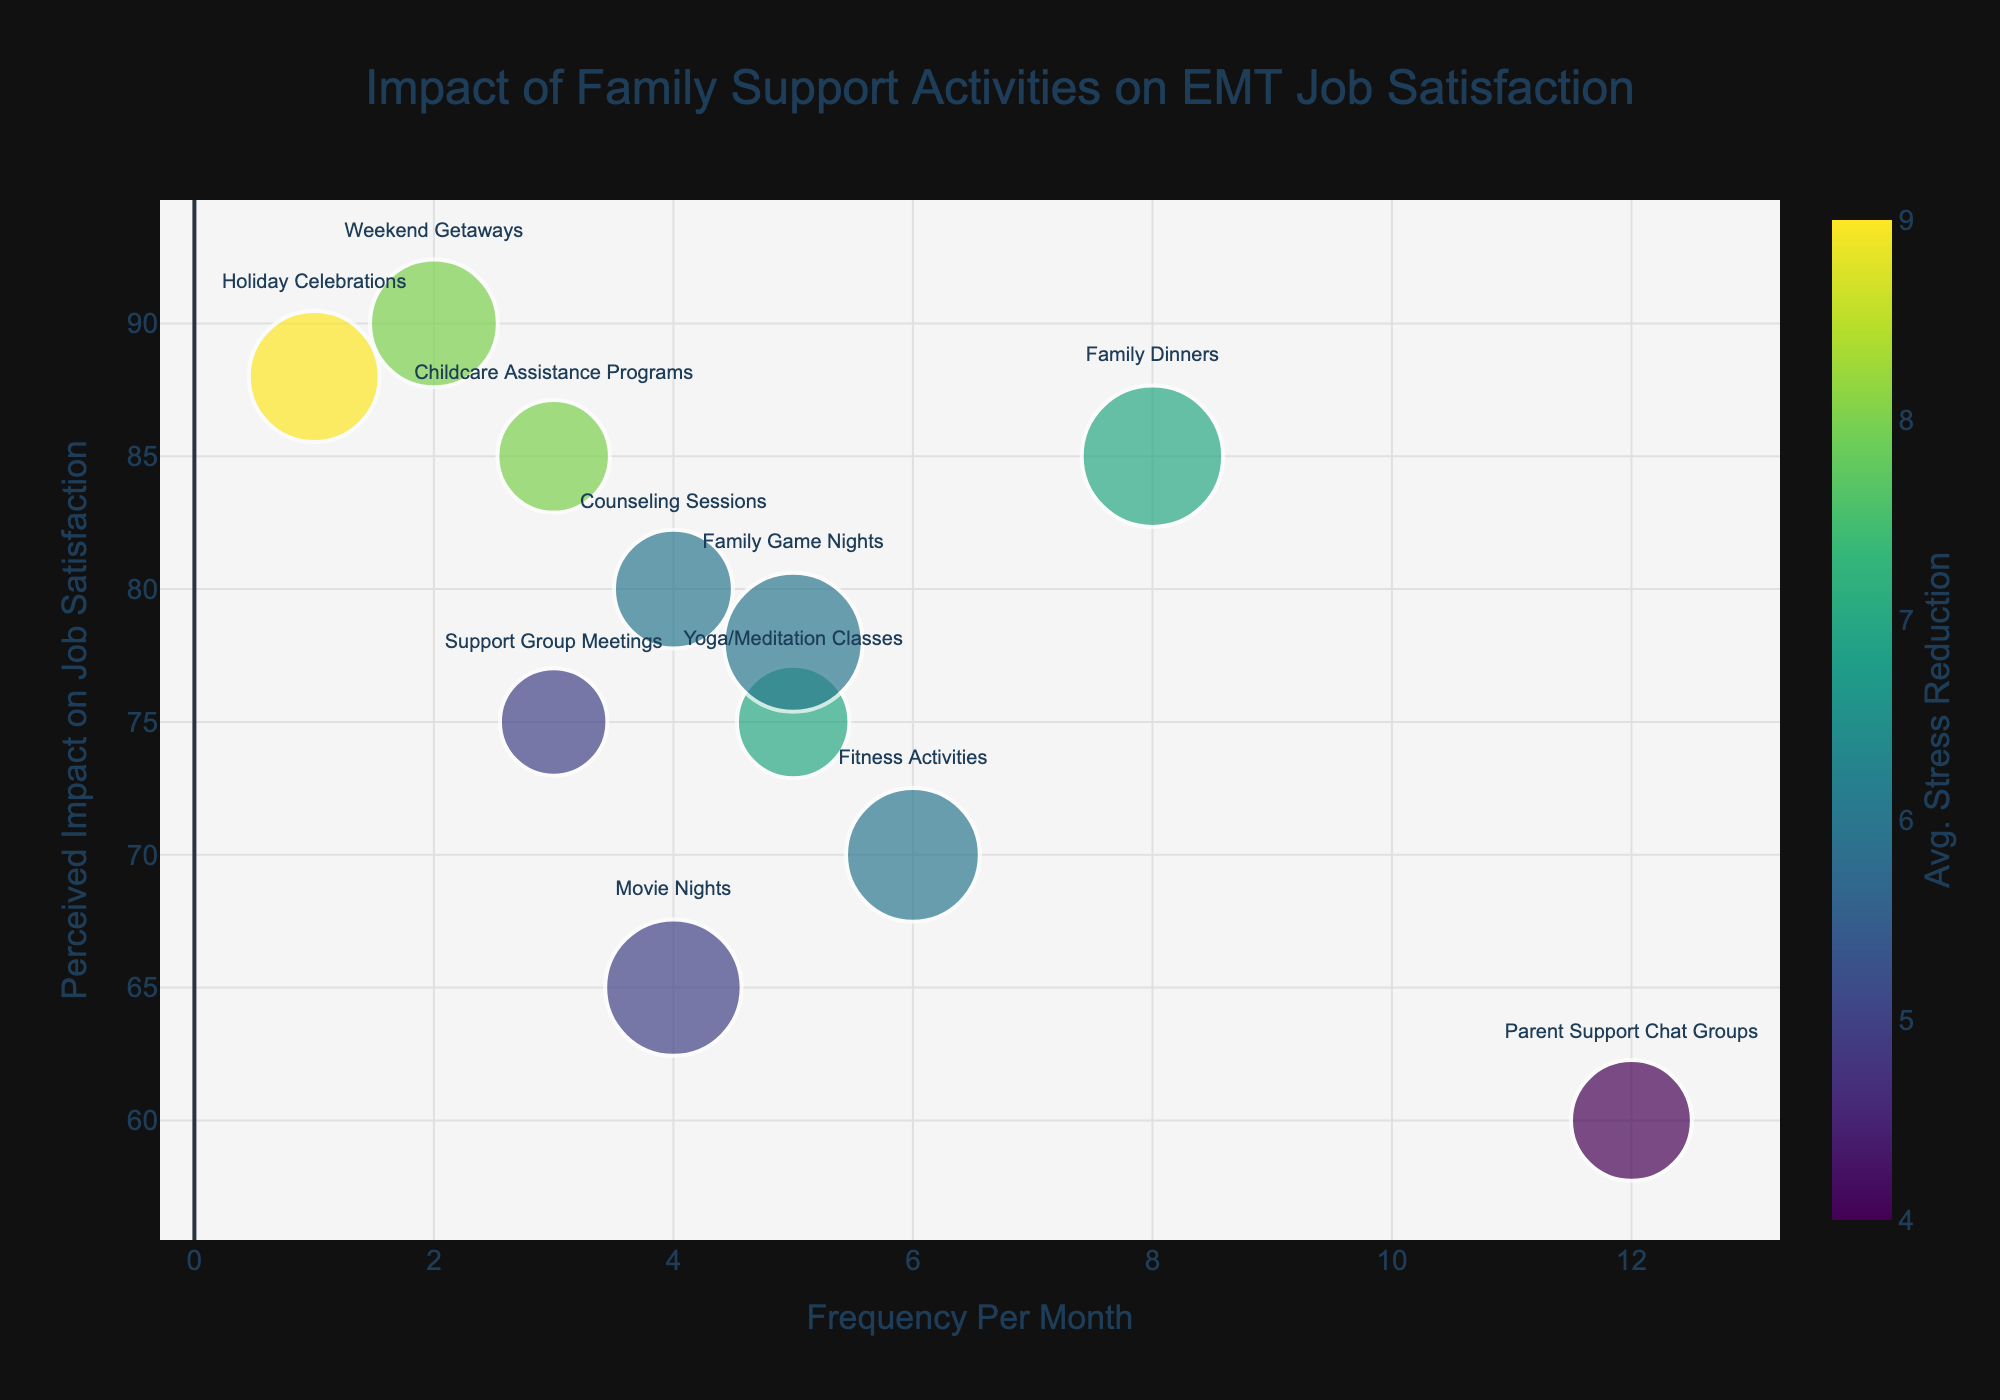What's the title of the chart? The title of the chart is usually located at the top of the figure; in this chart, it is "Impact of Family Support Activities on EMT Job Satisfaction."
Answer: Impact of Family Support Activities on EMT Job Satisfaction What activity has the highest perceived impact on job satisfaction? To find this, look at the y-axis which represents the "Perceived Impact on Job Satisfaction," and identify the activity with the highest value. "Weekend Getaways" has the highest perceived impact at 90.
Answer: Weekend Getaways How many activities have an average stress reduction score of 8? Examine the color coding for the bubbles and look for those corresponding to the stress reduction score of 8. Two activities, "Weekend Getaways" and "Childcare Assistance Programs," have this score.
Answer: 2 Which activity occurs most frequently per month? Look at the x-axis which measures "Frequency Per Month" and identify the activity at the far right. "Parent Support Chat Groups" occur the most frequently at 12 times per month.
Answer: Parent Support Chat Groups How many participants are there for activities with a stress reduction score of 7? Identify the activities with a stress reduction score of 7, which are "Family Dinners" and "Yoga/Meditation Classes." Sum their participants: 150 (Family Dinners) + 60 (Yoga/Meditation Classes) = 210.
Answer: 210 Which activity has the smallest bubble size? Bubble size is proportional to the square root of the number of participants, with the smallest bubble representing the lowest participant number. "Support Group Meetings," with 50 participants, is the smallest.
Answer: Support Group Meetings What is the perceived impact on job satisfaction for "Holiday Celebrations"? Locate "Holiday Celebrations" on the chart, and read the y-axis value corresponding to it. The perceived impact is 88.
Answer: 88 Do any two activities have the same frequency and perceived impact on job satisfaction? Compare values on both the x-axis (Frequency Per Month) and y-axis (Perceived Impact on Job Satisfaction) to see if any bubbles align in both dimensions. No two activities match both values equally.
Answer: No Which activity with 5 events per month has the highest average stress reduction? Identify activities with a frequency of 5 on the x-axis. Compare their stress reduction scores. "Yoga/Meditation Classes" has the highest with a score of 7.
Answer: Yoga/Meditation Classes What's the difference in job satisfaction impact between "Fitness Activities" and "Support Group Meetings"? Find the perceived impact on job satisfaction for both activities: "Fitness Activities" = 70, "Support Group Meetings" = 75. The difference is 75 - 70 = 5.
Answer: 5 